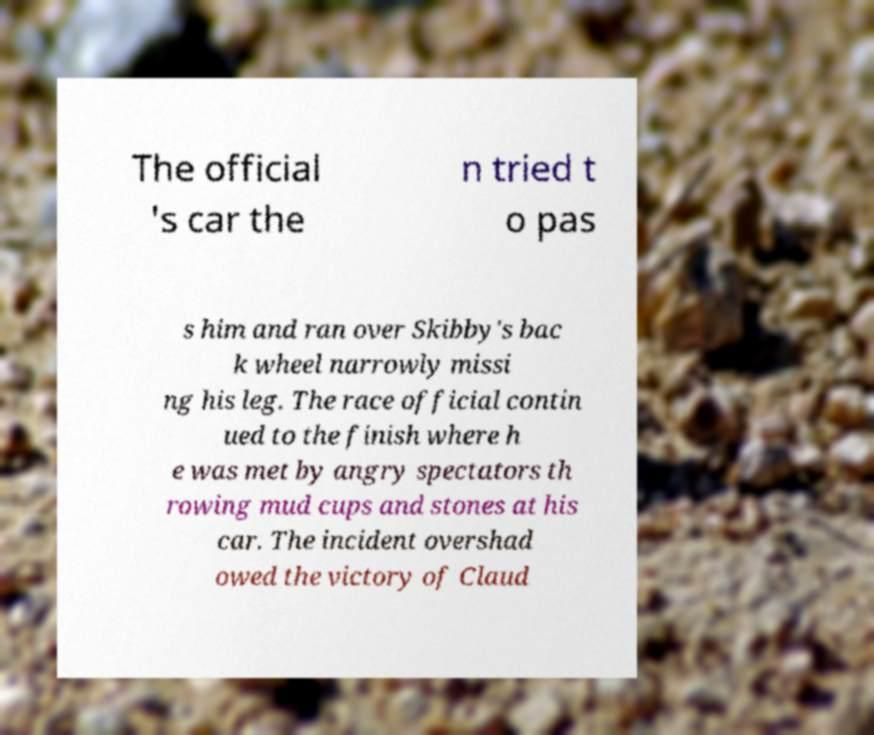Can you read and provide the text displayed in the image?This photo seems to have some interesting text. Can you extract and type it out for me? The official 's car the n tried t o pas s him and ran over Skibby's bac k wheel narrowly missi ng his leg. The race official contin ued to the finish where h e was met by angry spectators th rowing mud cups and stones at his car. The incident overshad owed the victory of Claud 